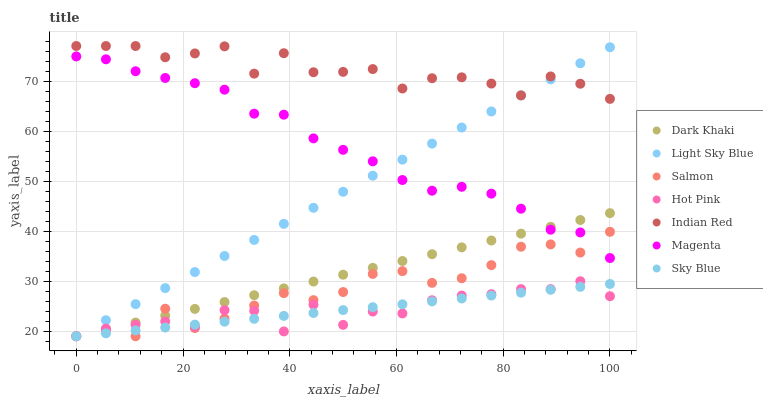Does Sky Blue have the minimum area under the curve?
Answer yes or no. Yes. Does Indian Red have the maximum area under the curve?
Answer yes or no. Yes. Does Salmon have the minimum area under the curve?
Answer yes or no. No. Does Salmon have the maximum area under the curve?
Answer yes or no. No. Is Light Sky Blue the smoothest?
Answer yes or no. Yes. Is Indian Red the roughest?
Answer yes or no. Yes. Is Salmon the smoothest?
Answer yes or no. No. Is Salmon the roughest?
Answer yes or no. No. Does Hot Pink have the lowest value?
Answer yes or no. Yes. Does Indian Red have the lowest value?
Answer yes or no. No. Does Indian Red have the highest value?
Answer yes or no. Yes. Does Salmon have the highest value?
Answer yes or no. No. Is Salmon less than Indian Red?
Answer yes or no. Yes. Is Indian Red greater than Dark Khaki?
Answer yes or no. Yes. Does Light Sky Blue intersect Indian Red?
Answer yes or no. Yes. Is Light Sky Blue less than Indian Red?
Answer yes or no. No. Is Light Sky Blue greater than Indian Red?
Answer yes or no. No. Does Salmon intersect Indian Red?
Answer yes or no. No. 